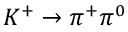Convert formula to latex. <formula><loc_0><loc_0><loc_500><loc_500>K ^ { + } \to \pi ^ { + } \pi ^ { 0 }</formula> 